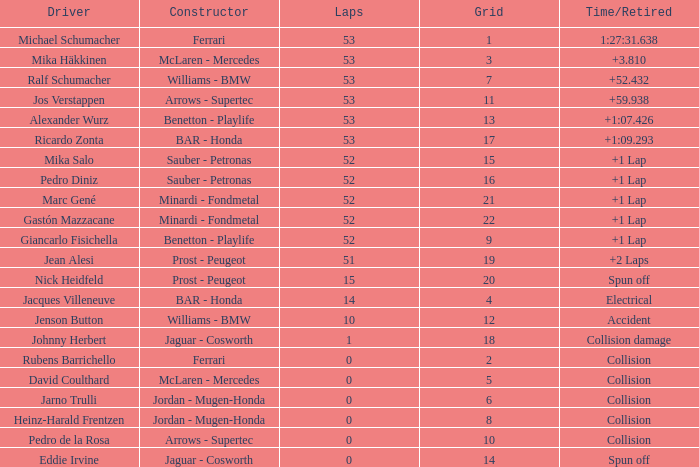What is the name of the driver with a grid less than 14, laps smaller than 53 and a Time/Retired of collision, and a Constructor of ferrari? Rubens Barrichello. 